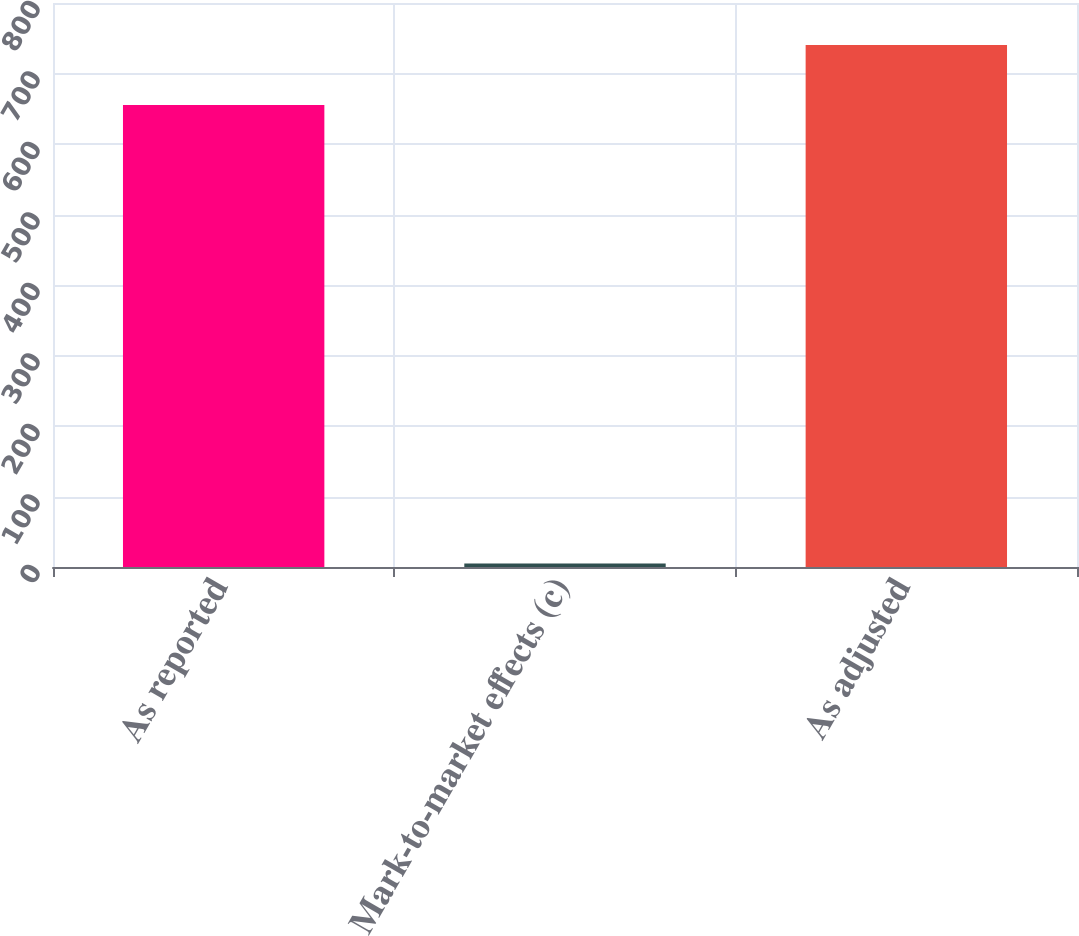Convert chart. <chart><loc_0><loc_0><loc_500><loc_500><bar_chart><fcel>As reported<fcel>Mark-to-market effects (c)<fcel>As adjusted<nl><fcel>655.2<fcel>5.1<fcel>740.3<nl></chart> 